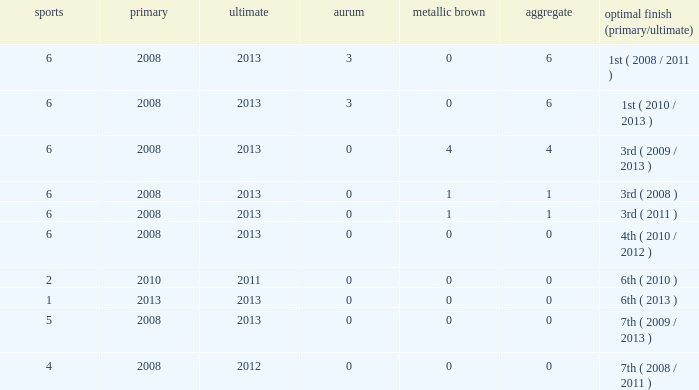In relation to more than 0 total medals, 3 golds, and over 6 games, what is the count of bronze medals? None. 